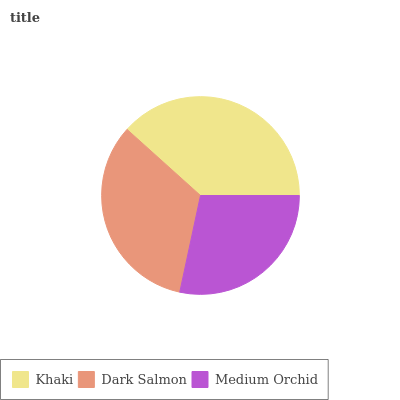Is Medium Orchid the minimum?
Answer yes or no. Yes. Is Khaki the maximum?
Answer yes or no. Yes. Is Dark Salmon the minimum?
Answer yes or no. No. Is Dark Salmon the maximum?
Answer yes or no. No. Is Khaki greater than Dark Salmon?
Answer yes or no. Yes. Is Dark Salmon less than Khaki?
Answer yes or no. Yes. Is Dark Salmon greater than Khaki?
Answer yes or no. No. Is Khaki less than Dark Salmon?
Answer yes or no. No. Is Dark Salmon the high median?
Answer yes or no. Yes. Is Dark Salmon the low median?
Answer yes or no. Yes. Is Medium Orchid the high median?
Answer yes or no. No. Is Khaki the low median?
Answer yes or no. No. 